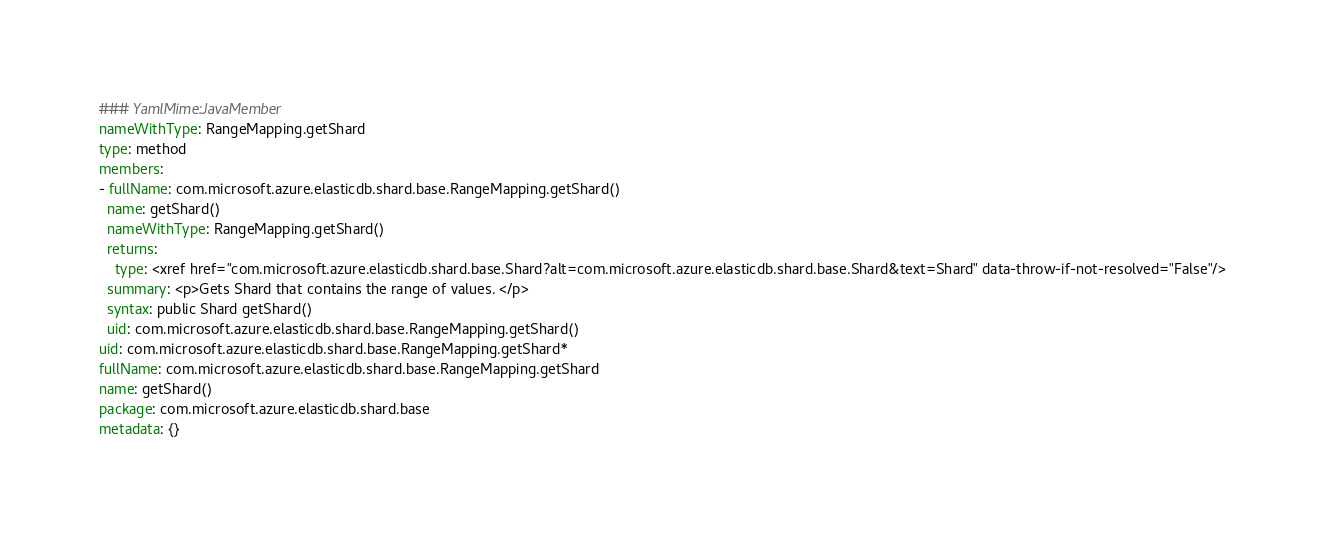Convert code to text. <code><loc_0><loc_0><loc_500><loc_500><_YAML_>### YamlMime:JavaMember
nameWithType: RangeMapping.getShard
type: method
members:
- fullName: com.microsoft.azure.elasticdb.shard.base.RangeMapping.getShard()
  name: getShard()
  nameWithType: RangeMapping.getShard()
  returns:
    type: <xref href="com.microsoft.azure.elasticdb.shard.base.Shard?alt=com.microsoft.azure.elasticdb.shard.base.Shard&text=Shard" data-throw-if-not-resolved="False"/>
  summary: <p>Gets Shard that contains the range of values. </p>
  syntax: public Shard getShard()
  uid: com.microsoft.azure.elasticdb.shard.base.RangeMapping.getShard()
uid: com.microsoft.azure.elasticdb.shard.base.RangeMapping.getShard*
fullName: com.microsoft.azure.elasticdb.shard.base.RangeMapping.getShard
name: getShard()
package: com.microsoft.azure.elasticdb.shard.base
metadata: {}
</code> 